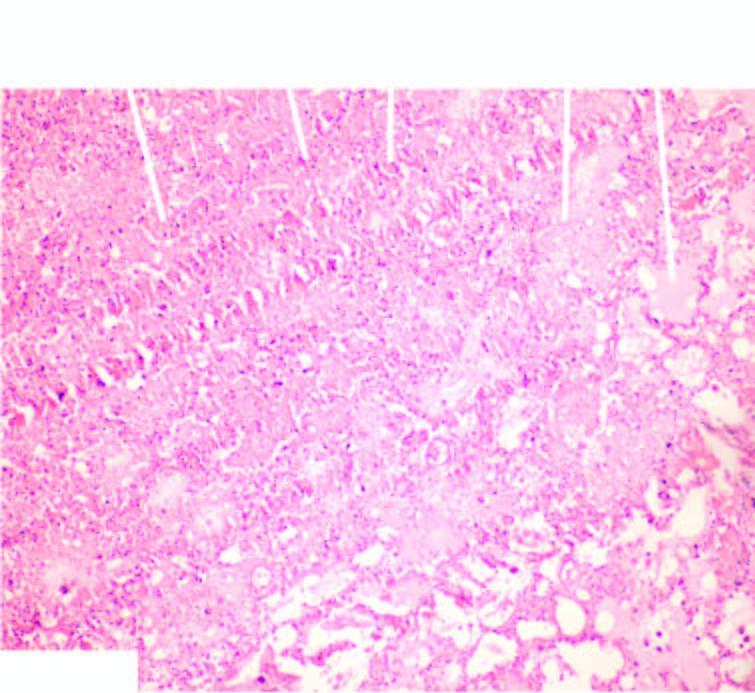does infarcted area show ghostal veoli filled with blood?
Answer the question using a single word or phrase. Yes 